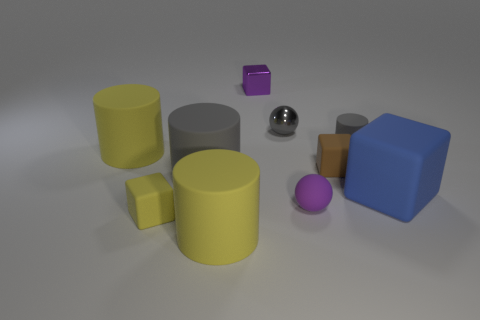There is another rubber block that is the same size as the yellow cube; what color is it?
Offer a terse response. Brown. There is a big yellow cylinder that is behind the small ball in front of the large yellow matte cylinder left of the yellow matte cube; what is its material?
Offer a very short reply. Rubber. There is a tiny metallic block; is it the same color as the small sphere in front of the big gray cylinder?
Give a very brief answer. Yes. How many things are small rubber cubes that are to the left of the brown rubber block or cylinders behind the blue matte cube?
Ensure brevity in your answer.  4. There is a large yellow object behind the yellow rubber cylinder in front of the rubber ball; what is its shape?
Offer a terse response. Cylinder. Is there a small purple sphere made of the same material as the brown cube?
Provide a short and direct response. Yes. The big matte object that is the same shape as the purple metallic object is what color?
Offer a terse response. Blue. Are there fewer metal spheres that are on the left side of the gray shiny thing than purple objects that are behind the big blue object?
Your answer should be very brief. Yes. How many other objects are the same shape as the small yellow thing?
Offer a very short reply. 3. Are there fewer small objects that are right of the brown thing than big purple matte spheres?
Your answer should be compact. No. 